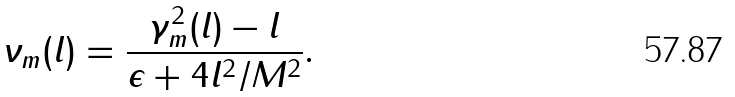Convert formula to latex. <formula><loc_0><loc_0><loc_500><loc_500>\nu _ { m } ( l ) = \frac { \gamma ^ { 2 } _ { m } ( l ) - l } { \epsilon + 4 l ^ { 2 } / M ^ { 2 } } .</formula> 